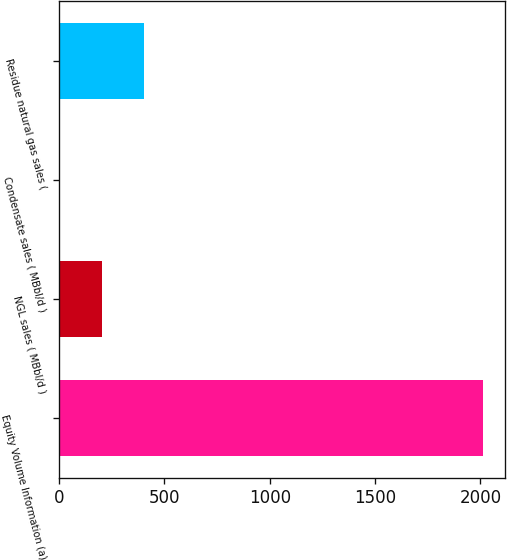Convert chart to OTSL. <chart><loc_0><loc_0><loc_500><loc_500><bar_chart><fcel>Equity Volume Information (a)<fcel>NGL sales ( MBbl/d )<fcel>Condensate sales ( MBbl/d )<fcel>Residue natural gas sales (<nl><fcel>2014<fcel>204.19<fcel>3.1<fcel>405.28<nl></chart> 